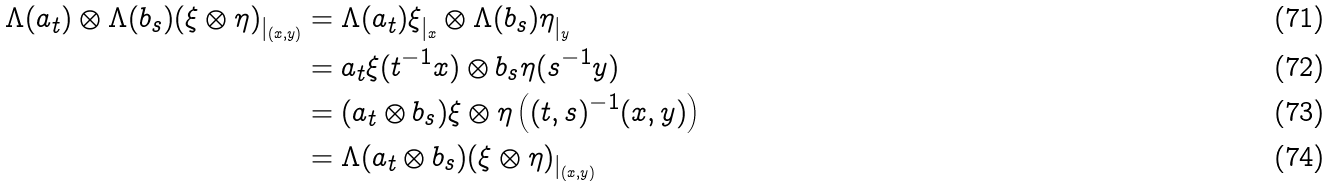<formula> <loc_0><loc_0><loc_500><loc_500>\Lambda ( a _ { t } ) \otimes \Lambda ( b _ { s } ) ( \xi \otimes \eta ) _ { | _ { ( x , y ) } } & = \Lambda ( a _ { t } ) \xi _ { | _ { x } } \otimes \Lambda ( b _ { s } ) \eta _ { | _ { y } } \\ & = a _ { t } \xi ( t ^ { - 1 } x ) \otimes b _ { s } \eta ( s ^ { - 1 } y ) \\ & = ( a _ { t } \otimes b _ { s } ) \xi \otimes \eta \left ( ( t , s ) ^ { - 1 } ( x , y ) \right ) \\ & = \Lambda ( a _ { t } \otimes b _ { s } ) ( \xi \otimes \eta ) _ { | _ { ( x , y ) } }</formula> 